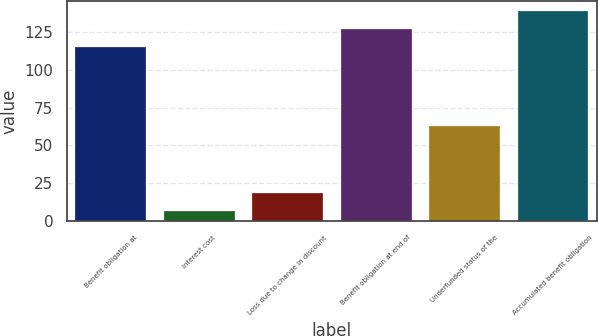<chart> <loc_0><loc_0><loc_500><loc_500><bar_chart><fcel>Benefit obligation at<fcel>Interest cost<fcel>Loss due to change in discount<fcel>Benefit obligation at end of<fcel>Underfunded status of the<fcel>Accumulated benefit obligation<nl><fcel>115<fcel>7<fcel>18.8<fcel>126.8<fcel>63<fcel>138.6<nl></chart> 